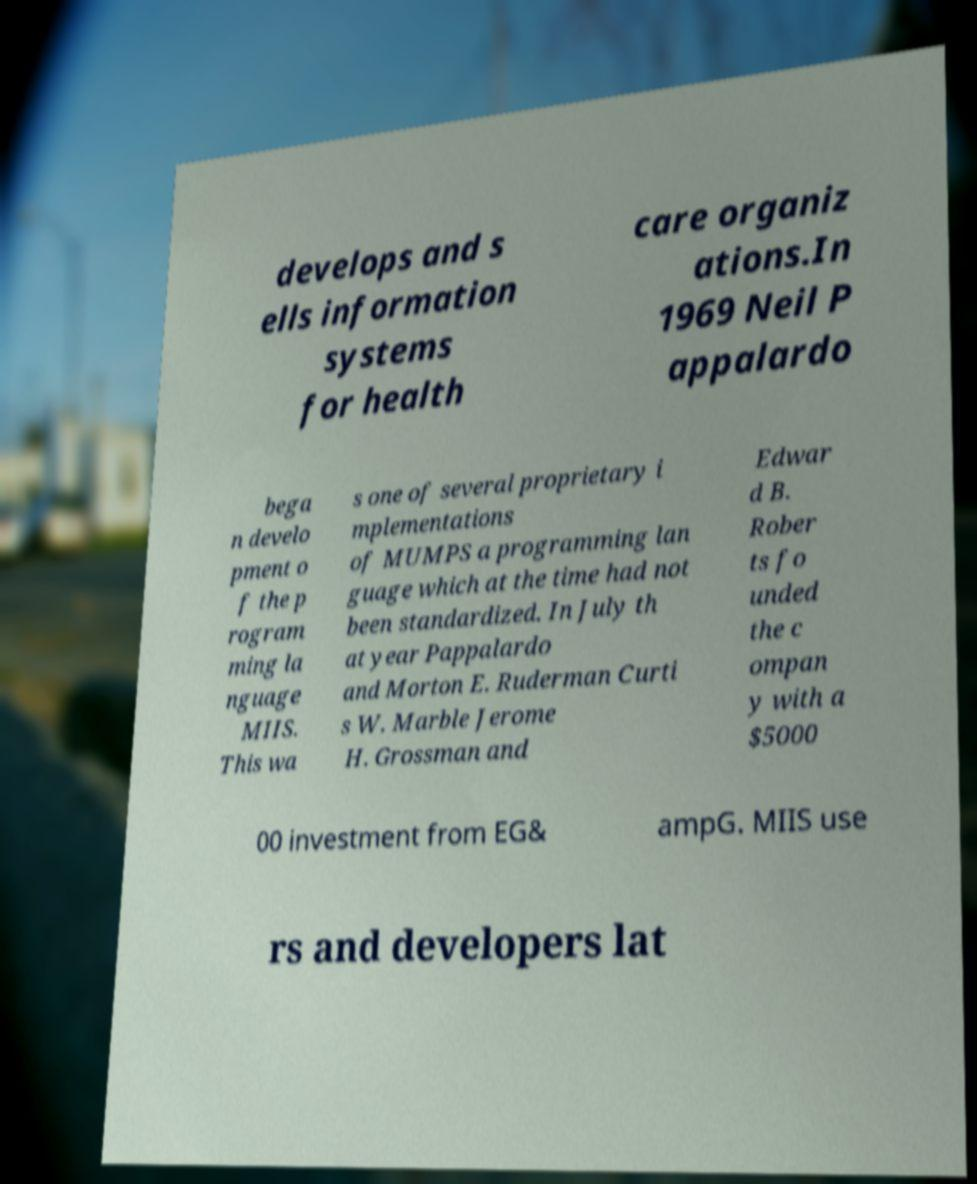Please identify and transcribe the text found in this image. develops and s ells information systems for health care organiz ations.In 1969 Neil P appalardo bega n develo pment o f the p rogram ming la nguage MIIS. This wa s one of several proprietary i mplementations of MUMPS a programming lan guage which at the time had not been standardized. In July th at year Pappalardo and Morton E. Ruderman Curti s W. Marble Jerome H. Grossman and Edwar d B. Rober ts fo unded the c ompan y with a $5000 00 investment from EG& ampG. MIIS use rs and developers lat 